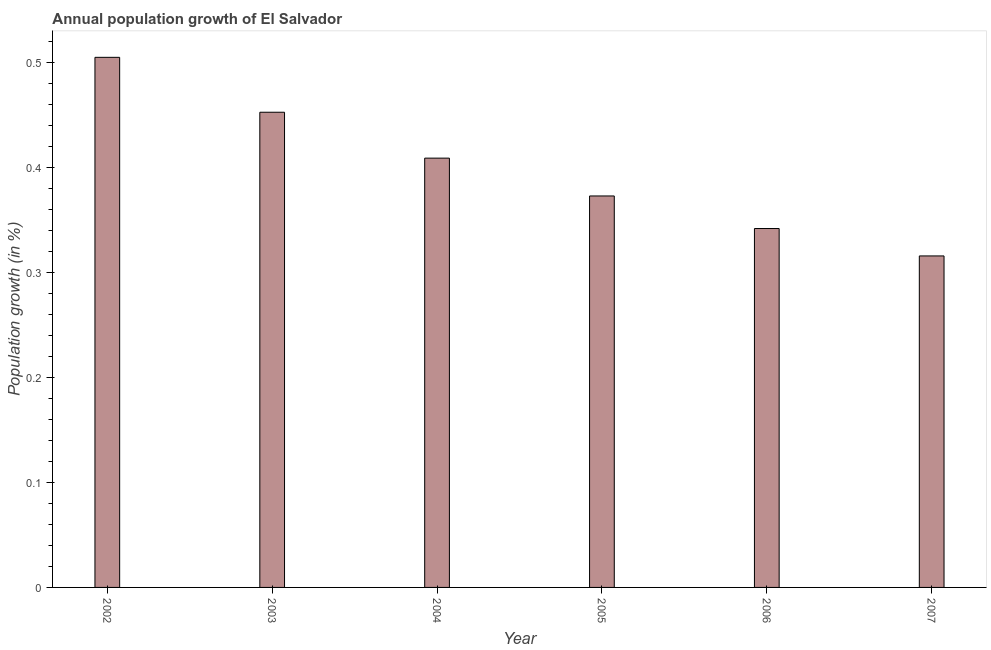What is the title of the graph?
Provide a short and direct response. Annual population growth of El Salvador. What is the label or title of the Y-axis?
Make the answer very short. Population growth (in %). What is the population growth in 2003?
Your answer should be compact. 0.45. Across all years, what is the maximum population growth?
Provide a succinct answer. 0.5. Across all years, what is the minimum population growth?
Give a very brief answer. 0.32. In which year was the population growth maximum?
Offer a terse response. 2002. What is the sum of the population growth?
Make the answer very short. 2.4. What is the difference between the population growth in 2004 and 2006?
Give a very brief answer. 0.07. What is the average population growth per year?
Provide a short and direct response. 0.4. What is the median population growth?
Offer a terse response. 0.39. In how many years, is the population growth greater than 0.04 %?
Make the answer very short. 6. What is the ratio of the population growth in 2003 to that in 2004?
Keep it short and to the point. 1.11. Is the population growth in 2004 less than that in 2005?
Your answer should be compact. No. What is the difference between the highest and the second highest population growth?
Provide a short and direct response. 0.05. Is the sum of the population growth in 2003 and 2007 greater than the maximum population growth across all years?
Give a very brief answer. Yes. What is the difference between the highest and the lowest population growth?
Provide a short and direct response. 0.19. How many bars are there?
Provide a short and direct response. 6. Are the values on the major ticks of Y-axis written in scientific E-notation?
Offer a terse response. No. What is the Population growth (in %) of 2002?
Give a very brief answer. 0.5. What is the Population growth (in %) of 2003?
Keep it short and to the point. 0.45. What is the Population growth (in %) in 2004?
Provide a succinct answer. 0.41. What is the Population growth (in %) of 2005?
Your response must be concise. 0.37. What is the Population growth (in %) of 2006?
Provide a short and direct response. 0.34. What is the Population growth (in %) of 2007?
Offer a terse response. 0.32. What is the difference between the Population growth (in %) in 2002 and 2003?
Offer a terse response. 0.05. What is the difference between the Population growth (in %) in 2002 and 2004?
Offer a very short reply. 0.1. What is the difference between the Population growth (in %) in 2002 and 2005?
Ensure brevity in your answer.  0.13. What is the difference between the Population growth (in %) in 2002 and 2006?
Offer a terse response. 0.16. What is the difference between the Population growth (in %) in 2002 and 2007?
Provide a short and direct response. 0.19. What is the difference between the Population growth (in %) in 2003 and 2004?
Your response must be concise. 0.04. What is the difference between the Population growth (in %) in 2003 and 2005?
Keep it short and to the point. 0.08. What is the difference between the Population growth (in %) in 2003 and 2006?
Offer a terse response. 0.11. What is the difference between the Population growth (in %) in 2003 and 2007?
Provide a succinct answer. 0.14. What is the difference between the Population growth (in %) in 2004 and 2005?
Keep it short and to the point. 0.04. What is the difference between the Population growth (in %) in 2004 and 2006?
Ensure brevity in your answer.  0.07. What is the difference between the Population growth (in %) in 2004 and 2007?
Provide a succinct answer. 0.09. What is the difference between the Population growth (in %) in 2005 and 2006?
Provide a succinct answer. 0.03. What is the difference between the Population growth (in %) in 2005 and 2007?
Make the answer very short. 0.06. What is the difference between the Population growth (in %) in 2006 and 2007?
Your answer should be compact. 0.03. What is the ratio of the Population growth (in %) in 2002 to that in 2003?
Offer a terse response. 1.12. What is the ratio of the Population growth (in %) in 2002 to that in 2004?
Give a very brief answer. 1.24. What is the ratio of the Population growth (in %) in 2002 to that in 2005?
Offer a terse response. 1.35. What is the ratio of the Population growth (in %) in 2002 to that in 2006?
Your answer should be very brief. 1.48. What is the ratio of the Population growth (in %) in 2002 to that in 2007?
Offer a very short reply. 1.6. What is the ratio of the Population growth (in %) in 2003 to that in 2004?
Your answer should be very brief. 1.11. What is the ratio of the Population growth (in %) in 2003 to that in 2005?
Ensure brevity in your answer.  1.21. What is the ratio of the Population growth (in %) in 2003 to that in 2006?
Keep it short and to the point. 1.32. What is the ratio of the Population growth (in %) in 2003 to that in 2007?
Make the answer very short. 1.43. What is the ratio of the Population growth (in %) in 2004 to that in 2005?
Ensure brevity in your answer.  1.1. What is the ratio of the Population growth (in %) in 2004 to that in 2006?
Give a very brief answer. 1.2. What is the ratio of the Population growth (in %) in 2004 to that in 2007?
Your answer should be compact. 1.29. What is the ratio of the Population growth (in %) in 2005 to that in 2006?
Make the answer very short. 1.09. What is the ratio of the Population growth (in %) in 2005 to that in 2007?
Ensure brevity in your answer.  1.18. What is the ratio of the Population growth (in %) in 2006 to that in 2007?
Ensure brevity in your answer.  1.08. 